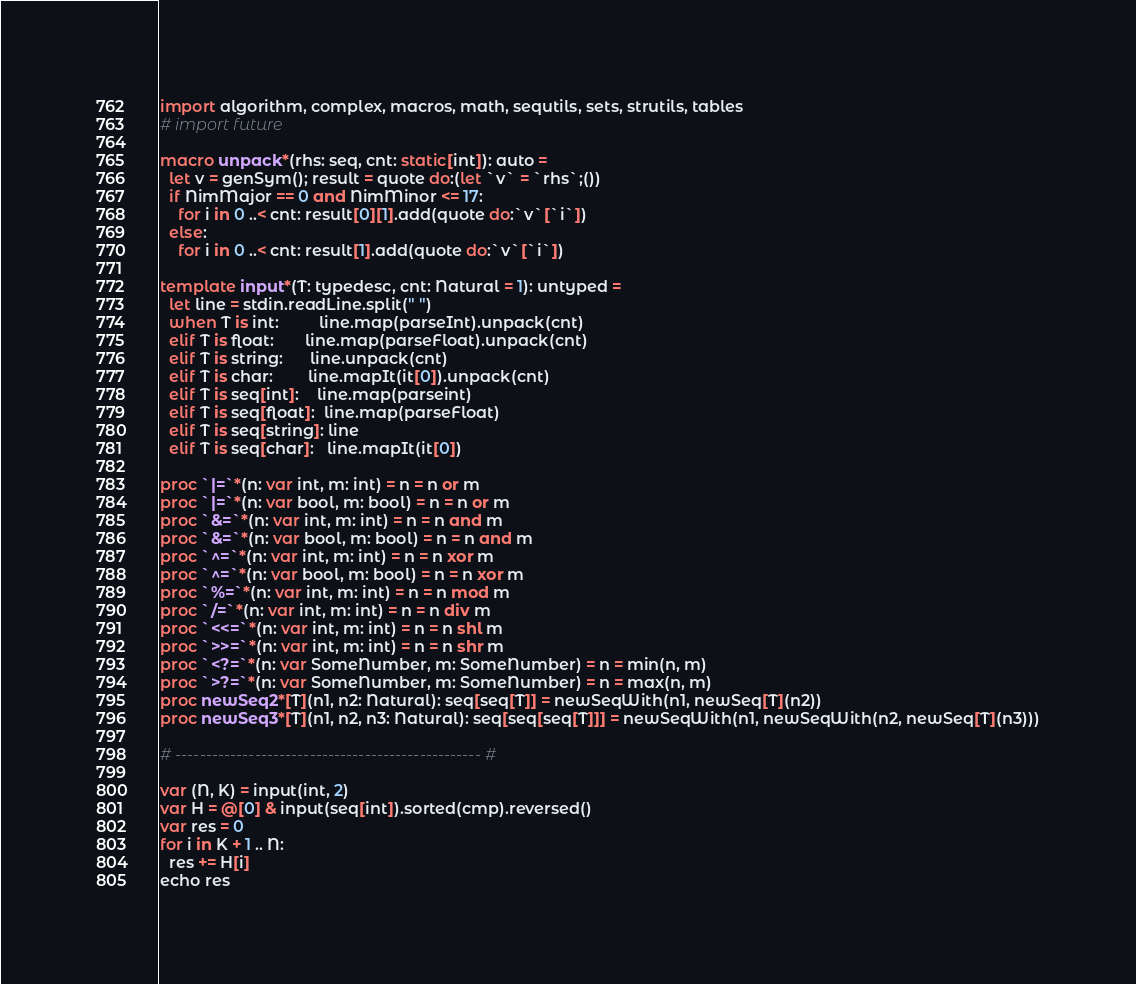Convert code to text. <code><loc_0><loc_0><loc_500><loc_500><_Nim_>import algorithm, complex, macros, math, sequtils, sets, strutils, tables
# import future

macro unpack*(rhs: seq, cnt: static[int]): auto =
  let v = genSym(); result = quote do:(let `v` = `rhs`;())
  if NimMajor == 0 and NimMinor <= 17:
    for i in 0 ..< cnt: result[0][1].add(quote do:`v`[`i`])
  else:
    for i in 0 ..< cnt: result[1].add(quote do:`v`[`i`])

template input*(T: typedesc, cnt: Natural = 1): untyped =
  let line = stdin.readLine.split(" ")
  when T is int:         line.map(parseInt).unpack(cnt)
  elif T is float:       line.map(parseFloat).unpack(cnt)
  elif T is string:      line.unpack(cnt)
  elif T is char:        line.mapIt(it[0]).unpack(cnt)
  elif T is seq[int]:    line.map(parseint)
  elif T is seq[float]:  line.map(parseFloat)
  elif T is seq[string]: line
  elif T is seq[char]:   line.mapIt(it[0])

proc `|=`*(n: var int, m: int) = n = n or m
proc `|=`*(n: var bool, m: bool) = n = n or m
proc `&=`*(n: var int, m: int) = n = n and m
proc `&=`*(n: var bool, m: bool) = n = n and m
proc `^=`*(n: var int, m: int) = n = n xor m
proc `^=`*(n: var bool, m: bool) = n = n xor m
proc `%=`*(n: var int, m: int) = n = n mod m
proc `/=`*(n: var int, m: int) = n = n div m
proc `<<=`*(n: var int, m: int) = n = n shl m
proc `>>=`*(n: var int, m: int) = n = n shr m
proc `<?=`*(n: var SomeNumber, m: SomeNumber) = n = min(n, m)
proc `>?=`*(n: var SomeNumber, m: SomeNumber) = n = max(n, m)
proc newSeq2*[T](n1, n2: Natural): seq[seq[T]] = newSeqWith(n1, newSeq[T](n2))
proc newSeq3*[T](n1, n2, n3: Natural): seq[seq[seq[T]]] = newSeqWith(n1, newSeqWith(n2, newSeq[T](n3)))

# -------------------------------------------------- #

var (N, K) = input(int, 2)
var H = @[0] & input(seq[int]).sorted(cmp).reversed()
var res = 0
for i in K + 1 .. N:
  res += H[i]
echo res</code> 